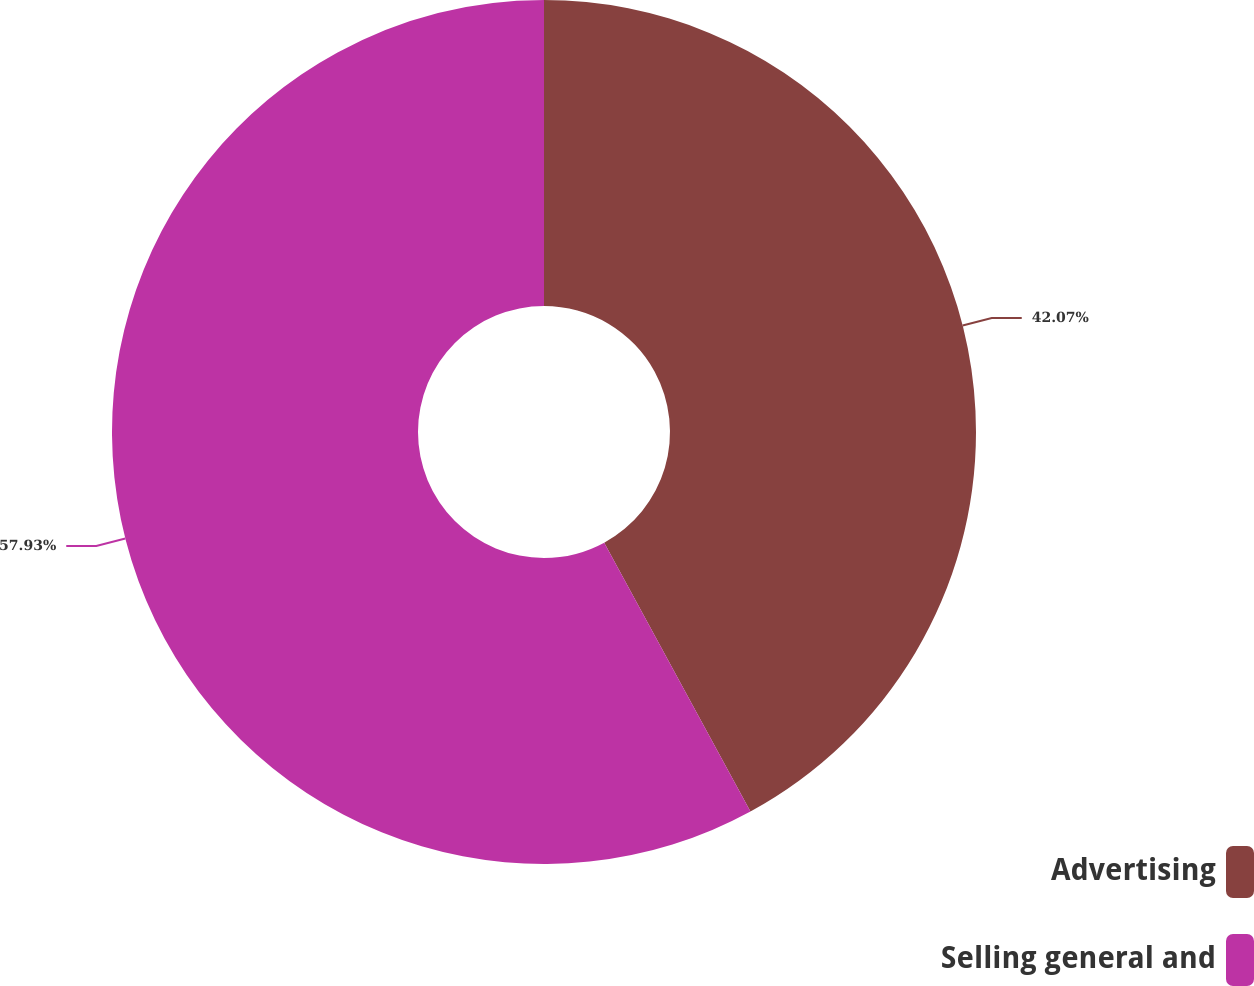Convert chart. <chart><loc_0><loc_0><loc_500><loc_500><pie_chart><fcel>Advertising<fcel>Selling general and<nl><fcel>42.07%<fcel>57.93%<nl></chart> 